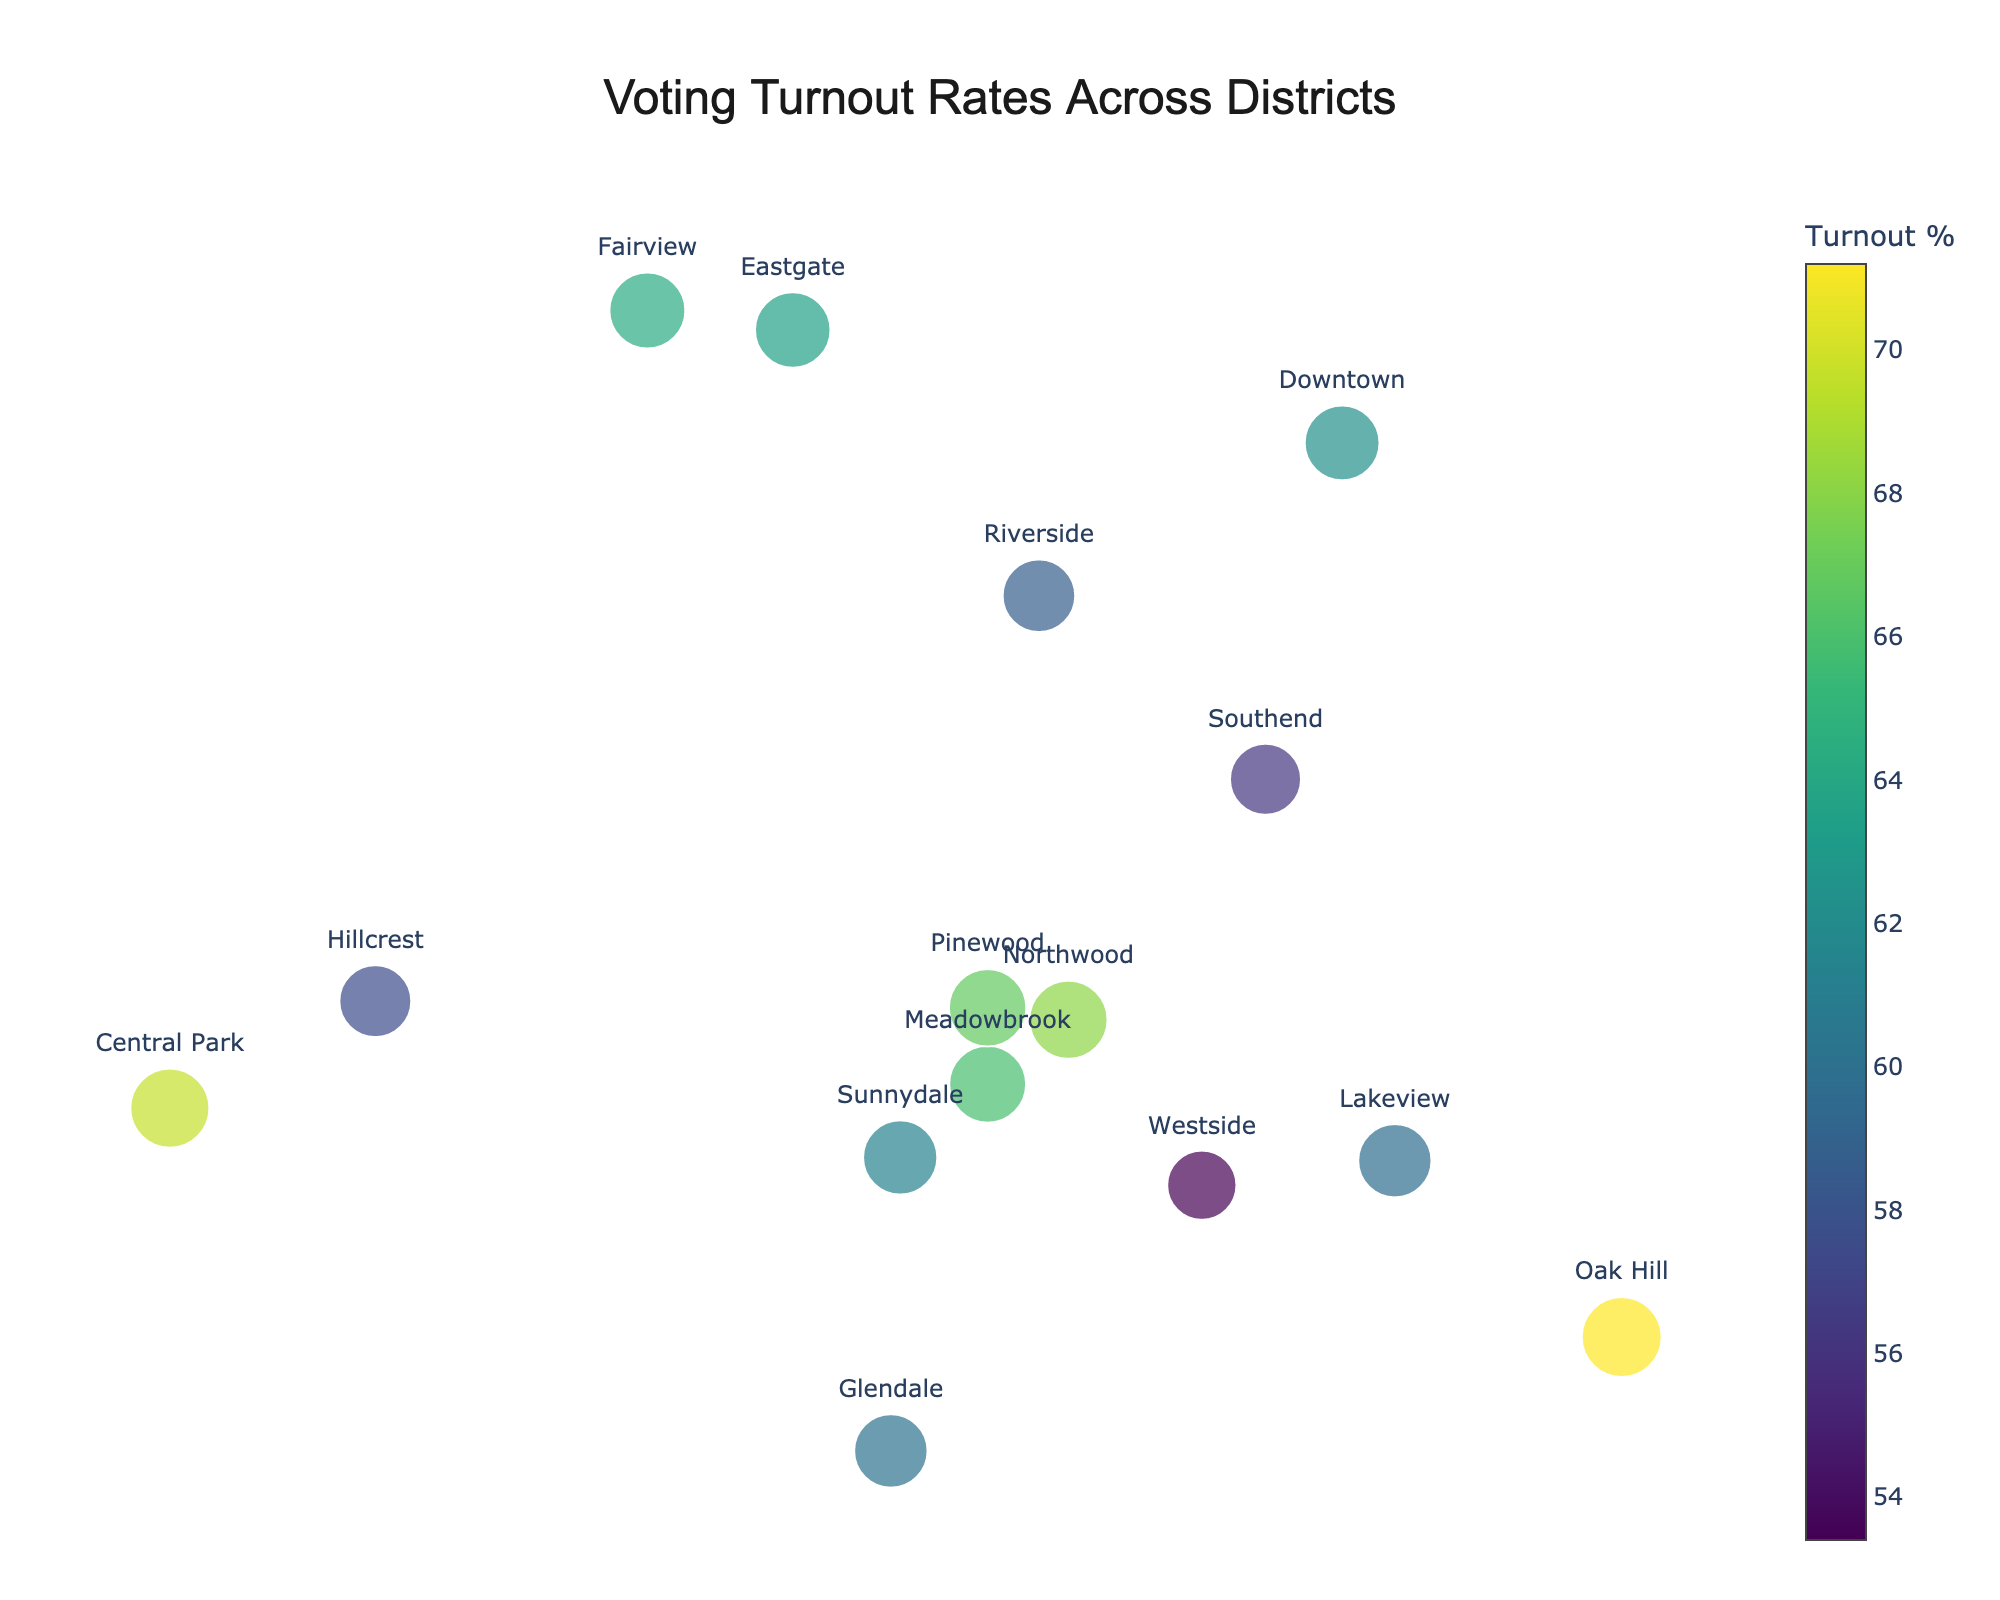What is the title of the figure? The title of a figure is usually displayed prominently at the top. In this case, the title is "Voting Turnout Rates Across Districts," as per the code provided.
Answer: Voting Turnout Rates Across Districts Which district had the highest turnout percentage? To identify the district with the highest turnout percentage, look for the one with the largest marker size and highest color intensity. According to the data, Oak Hill has the highest turnout percentage of 71.2%.
Answer: Oak Hill What is the turnout percentage for Downtown? Each marker's color and size indicate the turnout percentage. By matching the district labels to the percentage data, Downtown's turnout percentage can be identified as 62.3%.
Answer: 62.3% Which district has a turnout percentage above 70%? By examining the marker sizes and cross-referencing with the data, Oak Hill is the district with a turnout percentage above 70%, specifically 71.2%.
Answer: Oak Hill Compare the turnout percentages of Westside and Meadowbrook. Which is higher, and by how much? By looking at the color intensity and marker size, Meadowbrook's turnout (65.9%) can be compared to Westside's (53.4%). The difference is calculated as 65.9% - 53.4% = 12.5%.
Answer: Meadowbrook, by 12.5% How many districts have a turnout percentage below 60%? To answer this question, count the number of districts with markers representing turnout percentages below 60%. These districts are Riverside, Westside, Southend, Hillcrest, and Glendale, totaling 5 districts.
Answer: 5 What is the average turnout percentage of all districts? Summing all the turnout percentages and dividing by the number of districts: (62.3 + 58.7 + 71.2 + 65.9 + 53.4 + 68.1 + 59.8 + 56.2 + 63.5 + 69.7 + 57.6 + 61.4 + 66.8 + 60.1 + 64.3) / 15. This gives a total of 939.0 / 15 = 62.6% average turnout percentage.
Answer: 62.6% Is there a significant variation in voter turnout across districts? To determine the variation, observe the range of turnout percentages (53.4% to 71.2%). The difference of 17.8% suggests a significant variation in voter turnout.
Answer: Yes Which district has the lowest voter turnout? Finding the district with the smallest marker size and lowest color intensity reveals that Westside has the lowest voter turnout at 53.4%.
Answer: Westside What patterns can be deduced about the geographic distribution of voter turnout? By observing the figure, we can note that districts vary widely in turnout. Districts like Oak Hill and Central Park have high turnouts, while Westside has the lowest. No specific pattern related to geographic location is hinted at in the figure itself.
Answer: Varies widely, no specific geographic pattern noted 